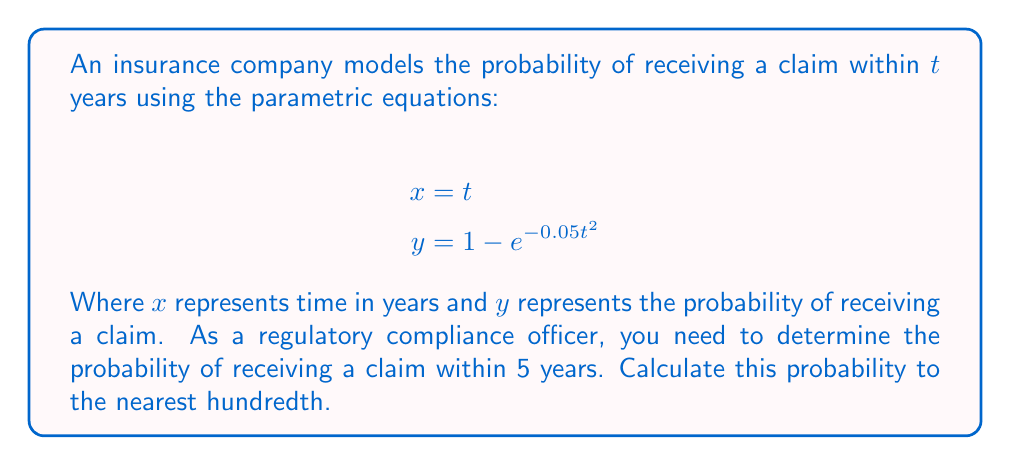Show me your answer to this math problem. To solve this problem, we need to follow these steps:

1. Understand the given parametric equations:
   $$x = t$$
   $$y = 1 - e^{-0.05t^2}$$

   Here, x represents time in years, and y represents the probability of receiving a claim.

2. We need to find the probability after 5 years, so we substitute t = 5 into the equation for y:

   $$y = 1 - e^{-0.05(5)^2}$$

3. Simplify the exponent:
   $$y = 1 - e^{-0.05(25)}$$
   $$y = 1 - e^{-1.25}$$

4. Calculate the value of $e^{-1.25}$ using a calculator:
   $$e^{-1.25} \approx 0.2865$$

5. Subtract this value from 1:
   $$y = 1 - 0.2865 = 0.7135$$

6. Round to the nearest hundredth:
   $$y \approx 0.71$$

Therefore, the probability of receiving a claim within 5 years is approximately 0.71 or 71%.
Answer: 0.71 or 71% 